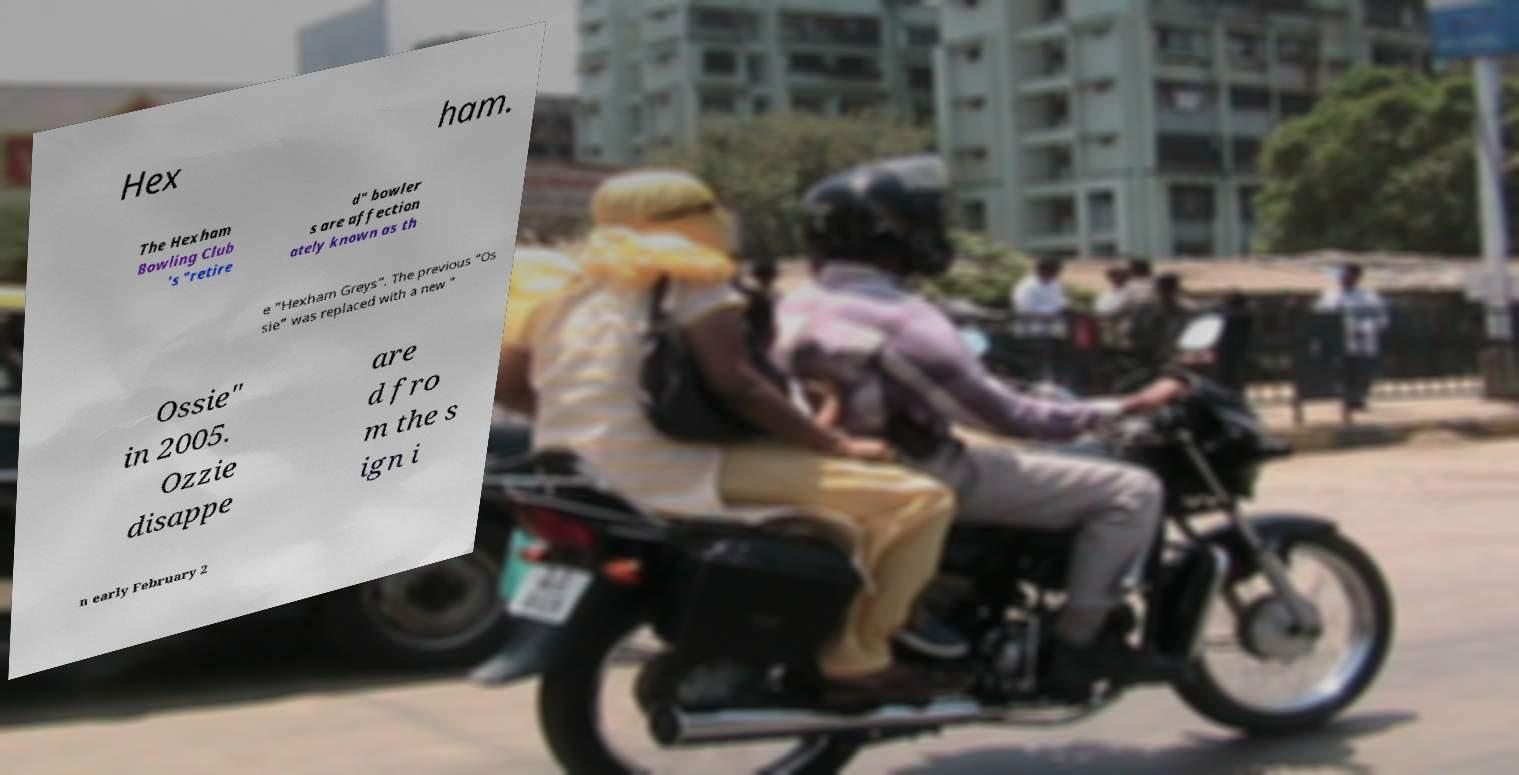Can you accurately transcribe the text from the provided image for me? Hex ham. The Hexham Bowling Club 's "retire d" bowler s are affection ately known as th e "Hexham Greys". The previous "Os sie" was replaced with a new " Ossie" in 2005. Ozzie disappe are d fro m the s ign i n early February 2 